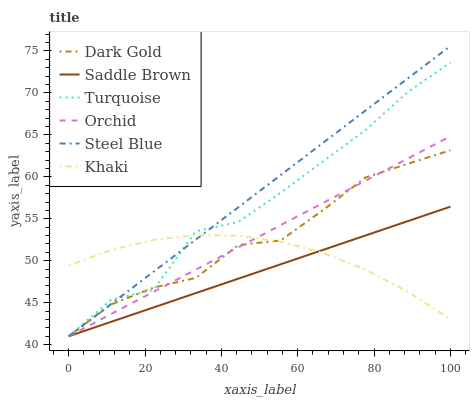Does Saddle Brown have the minimum area under the curve?
Answer yes or no. Yes. Does Steel Blue have the maximum area under the curve?
Answer yes or no. Yes. Does Khaki have the minimum area under the curve?
Answer yes or no. No. Does Khaki have the maximum area under the curve?
Answer yes or no. No. Is Steel Blue the smoothest?
Answer yes or no. Yes. Is Turquoise the roughest?
Answer yes or no. Yes. Is Khaki the smoothest?
Answer yes or no. No. Is Khaki the roughest?
Answer yes or no. No. Does Turquoise have the lowest value?
Answer yes or no. Yes. Does Khaki have the lowest value?
Answer yes or no. No. Does Steel Blue have the highest value?
Answer yes or no. Yes. Does Dark Gold have the highest value?
Answer yes or no. No. Does Turquoise intersect Khaki?
Answer yes or no. Yes. Is Turquoise less than Khaki?
Answer yes or no. No. Is Turquoise greater than Khaki?
Answer yes or no. No. 